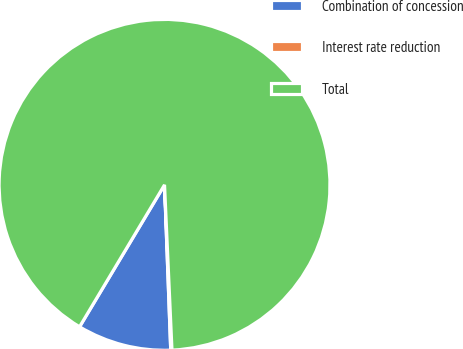Convert chart. <chart><loc_0><loc_0><loc_500><loc_500><pie_chart><fcel>Combination of concession<fcel>Interest rate reduction<fcel>Total<nl><fcel>9.18%<fcel>0.12%<fcel>90.7%<nl></chart> 